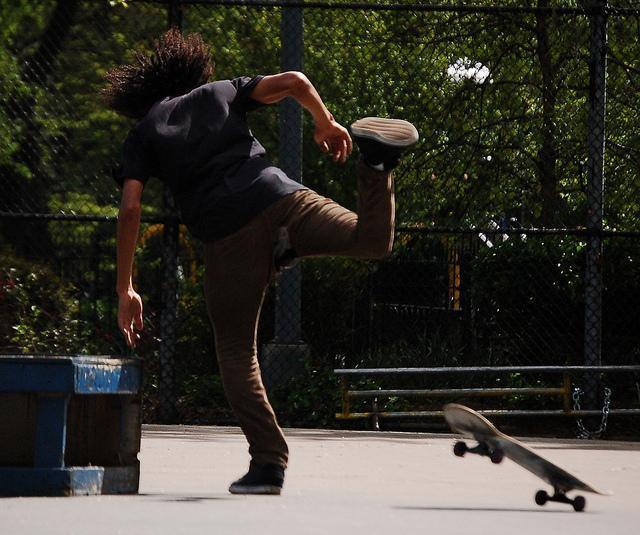How many skateboards can be seen?
Give a very brief answer. 1. 